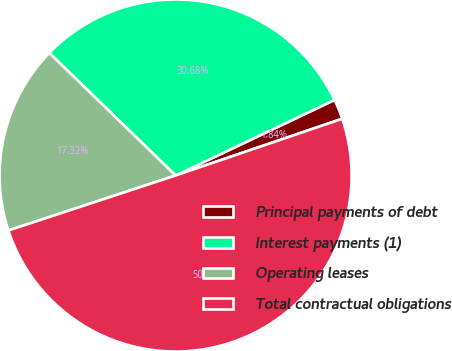Convert chart. <chart><loc_0><loc_0><loc_500><loc_500><pie_chart><fcel>Principal payments of debt<fcel>Interest payments (1)<fcel>Operating leases<fcel>Total contractual obligations<nl><fcel>1.84%<fcel>30.68%<fcel>17.32%<fcel>50.17%<nl></chart> 